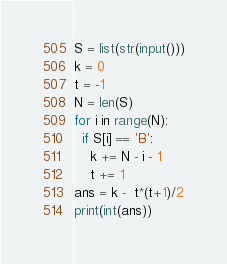<code> <loc_0><loc_0><loc_500><loc_500><_Python_>S = list(str(input()))
k = 0
t = -1
N = len(S)
for i in range(N):
  if S[i] == 'B':
    k += N - i - 1
    t += 1
ans = k -  t*(t+1)/2
print(int(ans))</code> 